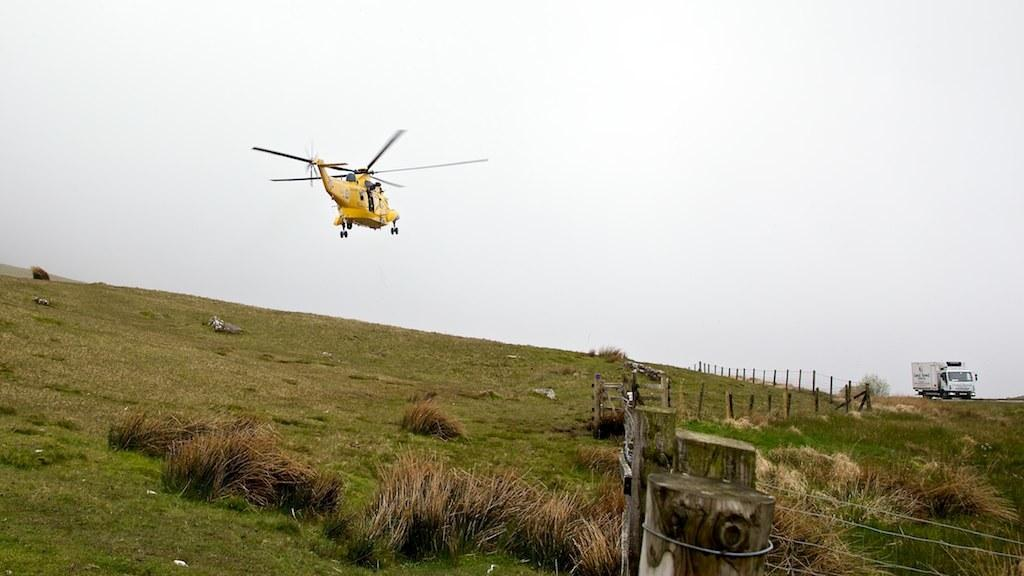What is flying above the ground in the image? There is an aeroplane flying above the ground in the image. What type of vegetation can be seen on the ground? Grass is visible on the ground. What is located on the ground near the grass? There is a fence and a vehicle on the ground. What can be seen in the background of the image? The sky is visible in the image. What type of cub is playing with oatmeal in the image? There is no cub or oatmeal present in the image; it features an aeroplane flying above the ground, grass, a fence, a vehicle, and the sky. What type of yam is growing near the fence in the image? There is no yam present in the image; it features an aeroplane flying above the ground, grass, a fence, a vehicle, and the sky. 